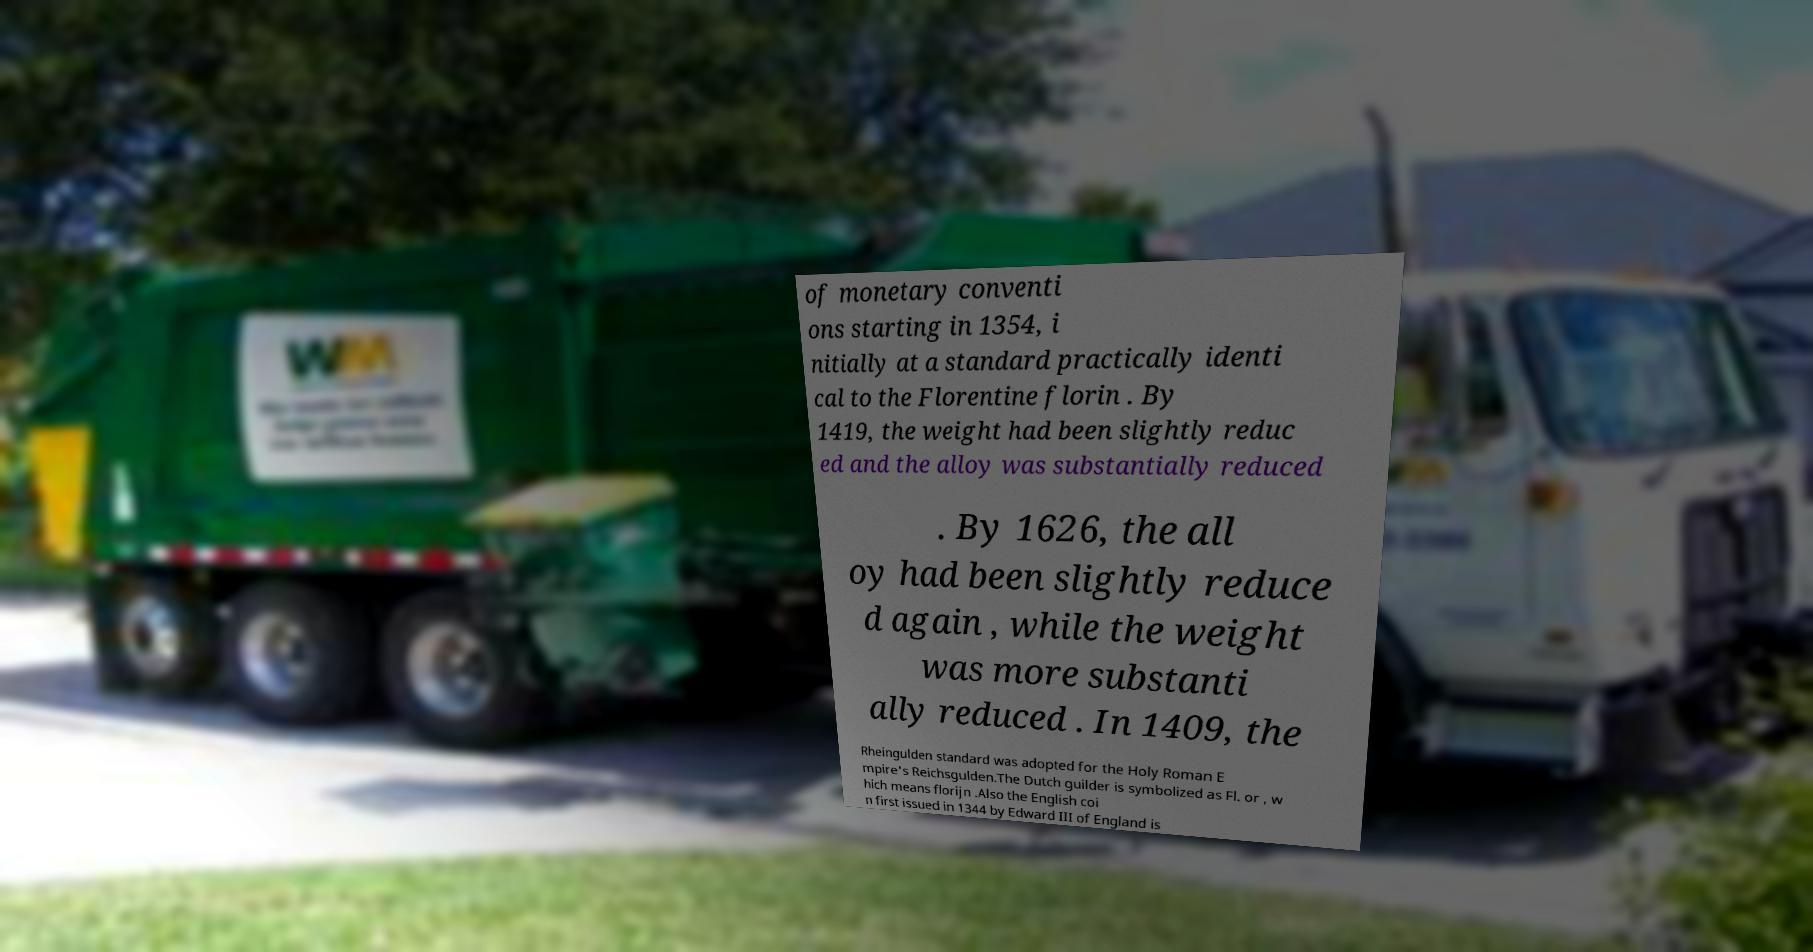For documentation purposes, I need the text within this image transcribed. Could you provide that? of monetary conventi ons starting in 1354, i nitially at a standard practically identi cal to the Florentine florin . By 1419, the weight had been slightly reduc ed and the alloy was substantially reduced . By 1626, the all oy had been slightly reduce d again , while the weight was more substanti ally reduced . In 1409, the Rheingulden standard was adopted for the Holy Roman E mpire's Reichsgulden.The Dutch guilder is symbolized as Fl. or , w hich means florijn .Also the English coi n first issued in 1344 by Edward III of England is 